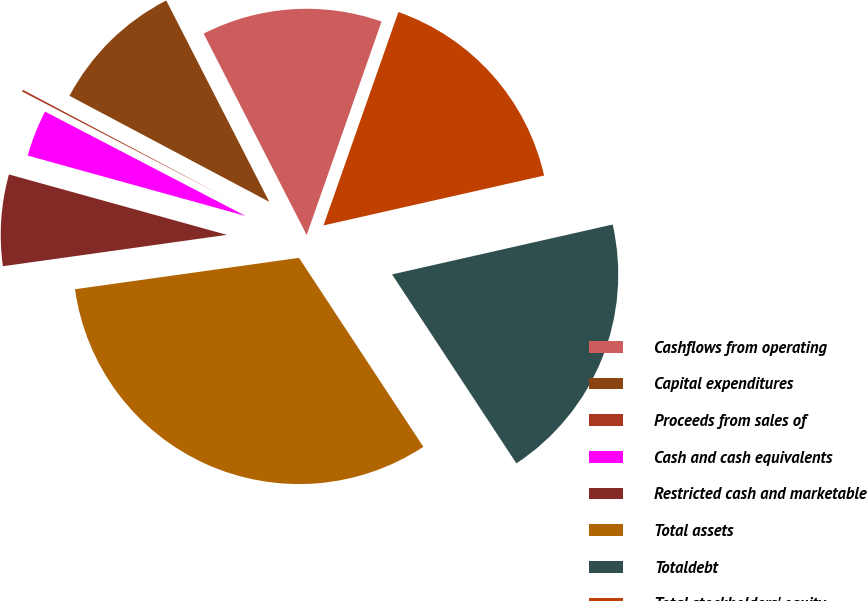Convert chart. <chart><loc_0><loc_0><loc_500><loc_500><pie_chart><fcel>Cashflows from operating<fcel>Capital expenditures<fcel>Proceeds from sales of<fcel>Cash and cash equivalents<fcel>Restricted cash and marketable<fcel>Total assets<fcel>Totaldebt<fcel>Total stockholders' equity<nl><fcel>12.9%<fcel>9.71%<fcel>0.13%<fcel>3.33%<fcel>6.52%<fcel>32.05%<fcel>19.28%<fcel>16.09%<nl></chart> 